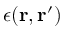Convert formula to latex. <formula><loc_0><loc_0><loc_500><loc_500>\epsilon ( r , r ^ { \prime } )</formula> 